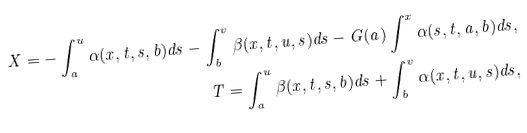Convert formula to latex. <formula><loc_0><loc_0><loc_500><loc_500>X = - \int _ { a } ^ { u } { \alpha ( x , t , s , b ) d s } - \int _ { b } ^ { v } { \beta ( x , t , u , s ) d s } - G ( a ) \int ^ { x } { \alpha ( s , t , a , b ) d s } , \\ T = \int _ { a } ^ { u } \beta ( x , t , s , b ) d s + \int _ { b } ^ { v } \alpha ( x , t , u , s ) d s ,</formula> 